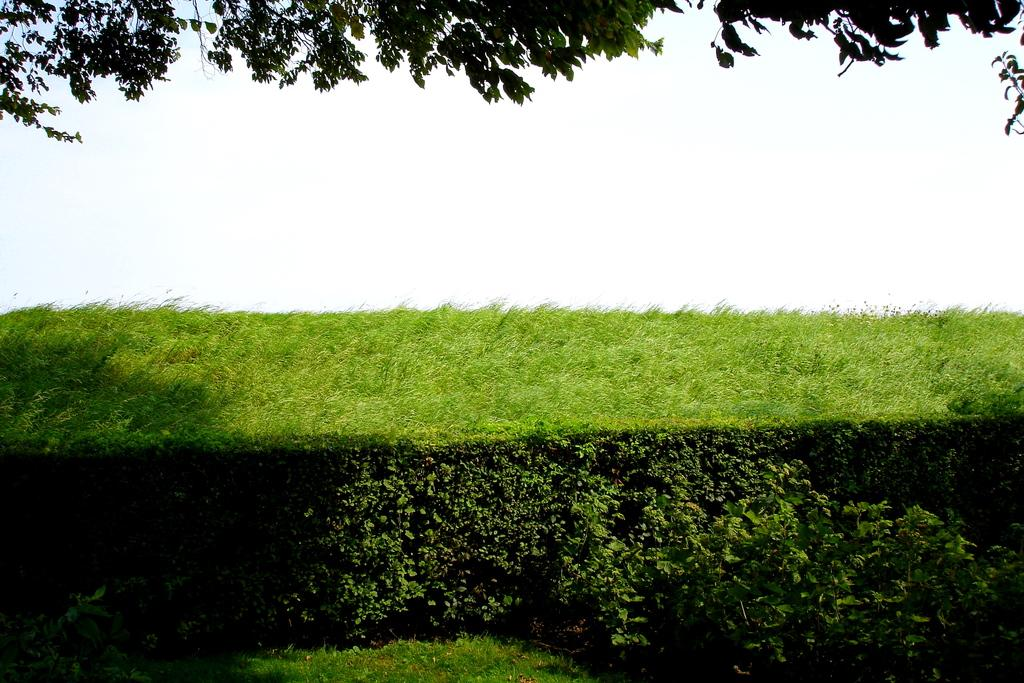What type of vegetation can be seen in the image? There is a bush in the image. What else can be seen in the image besides the bush? Trees are visible at the top of the image. What letters are causing trouble for the bush in the image? There are no letters present in the image, and the bush is not experiencing any trouble. 